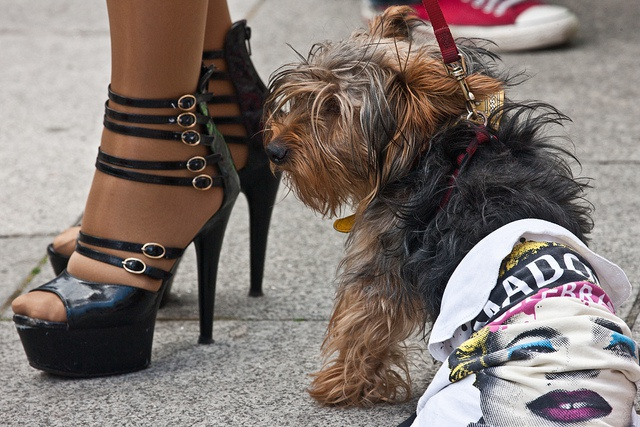Describe the objects in this image and their specific colors. I can see dog in lightgray, black, gray, and maroon tones, people in lightgray, black, brown, and maroon tones, and people in lightgray, darkgray, and brown tones in this image. 